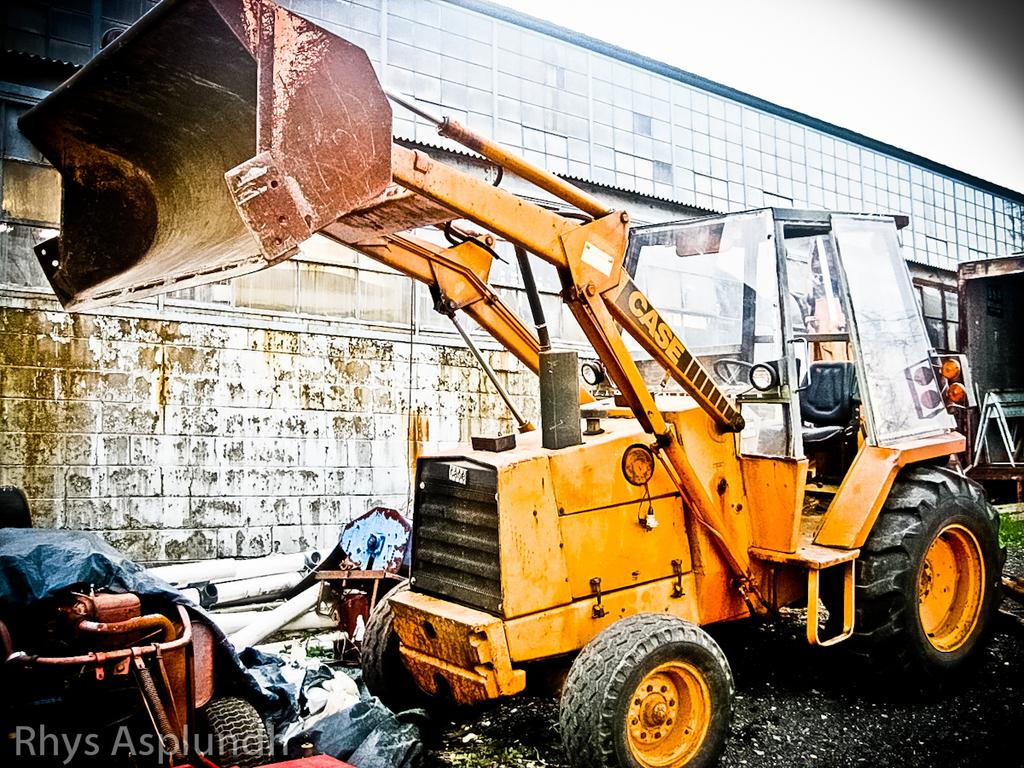What is the main subject in the image? There is a vehicle in the image. What can be seen beside the vehicle? There are pipes and other unspecified things beside the vehicle. What is visible in the background of the image? There is a building in the background of the image. What type of hand can be seen holding the vehicle in the image? There is no hand holding the vehicle in the image; it is stationary on the ground. 